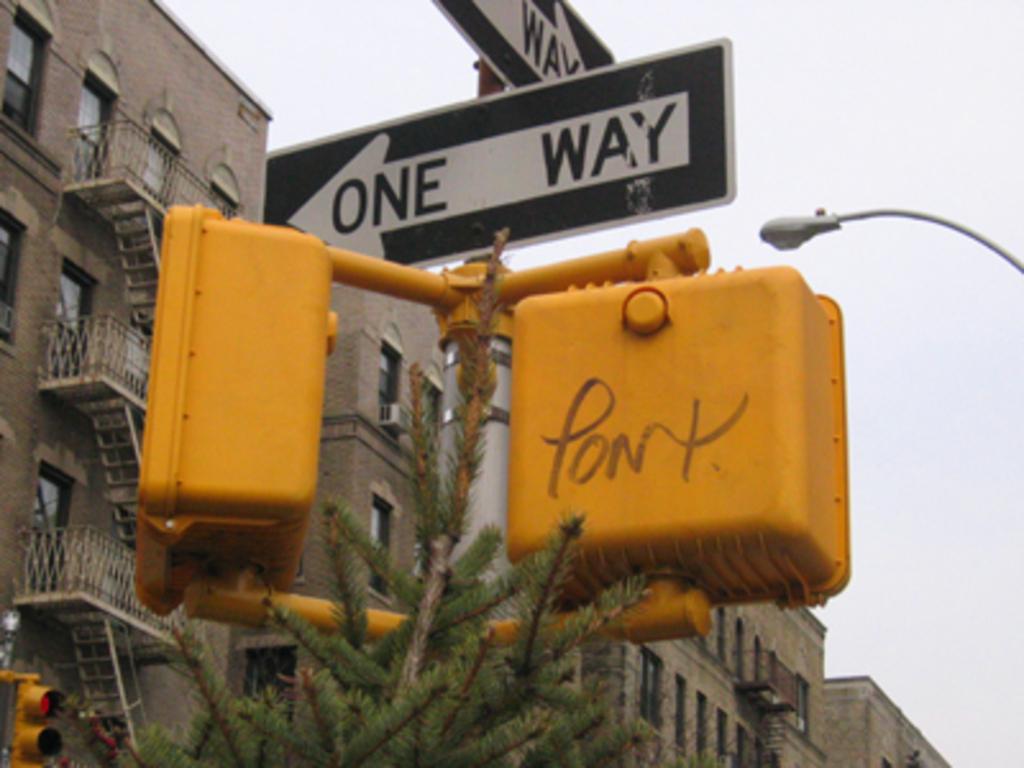What does the arrow say?
Your answer should be compact. One way. What is written on the yellow traffic light?
Your response must be concise. Pont. 